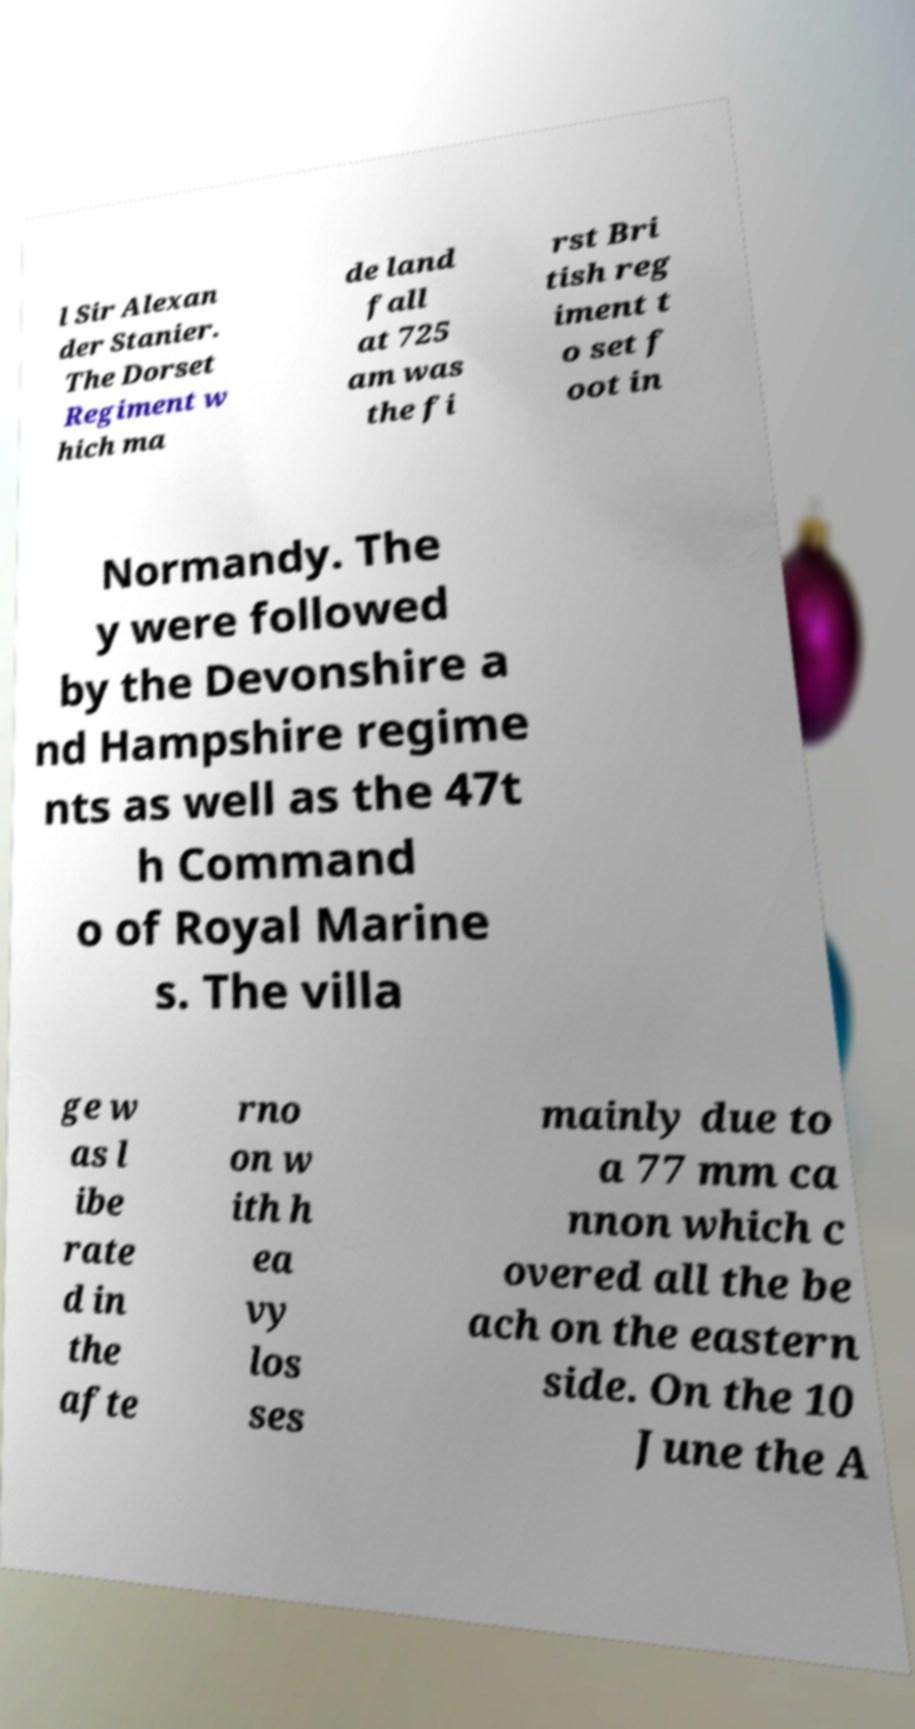For documentation purposes, I need the text within this image transcribed. Could you provide that? l Sir Alexan der Stanier. The Dorset Regiment w hich ma de land fall at 725 am was the fi rst Bri tish reg iment t o set f oot in Normandy. The y were followed by the Devonshire a nd Hampshire regime nts as well as the 47t h Command o of Royal Marine s. The villa ge w as l ibe rate d in the afte rno on w ith h ea vy los ses mainly due to a 77 mm ca nnon which c overed all the be ach on the eastern side. On the 10 June the A 